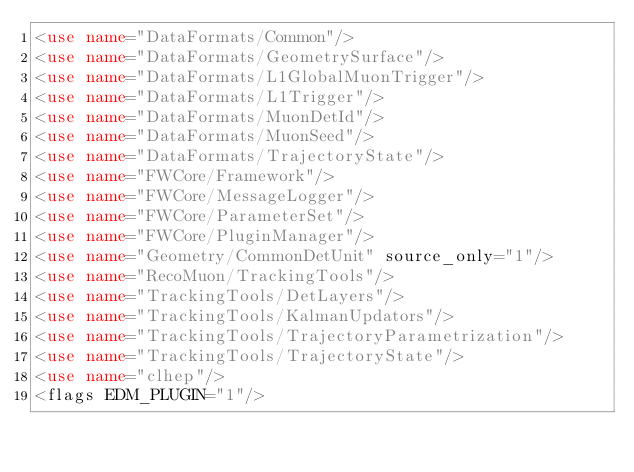Convert code to text. <code><loc_0><loc_0><loc_500><loc_500><_XML_><use name="DataFormats/Common"/>
<use name="DataFormats/GeometrySurface"/>
<use name="DataFormats/L1GlobalMuonTrigger"/>
<use name="DataFormats/L1Trigger"/>
<use name="DataFormats/MuonDetId"/>
<use name="DataFormats/MuonSeed"/>
<use name="DataFormats/TrajectoryState"/>
<use name="FWCore/Framework"/>
<use name="FWCore/MessageLogger"/>
<use name="FWCore/ParameterSet"/>
<use name="FWCore/PluginManager"/>
<use name="Geometry/CommonDetUnit" source_only="1"/>
<use name="RecoMuon/TrackingTools"/>
<use name="TrackingTools/DetLayers"/>
<use name="TrackingTools/KalmanUpdators"/>
<use name="TrackingTools/TrajectoryParametrization"/>
<use name="TrackingTools/TrajectoryState"/>
<use name="clhep"/>
<flags EDM_PLUGIN="1"/>
</code> 